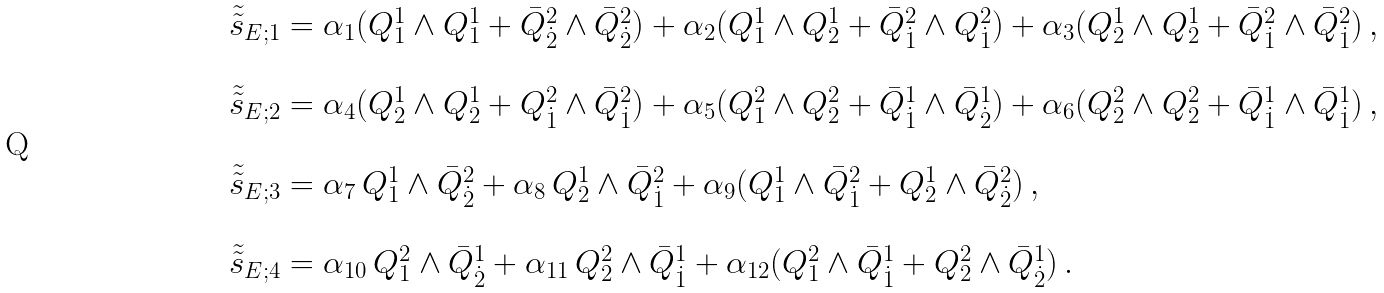<formula> <loc_0><loc_0><loc_500><loc_500>\begin{array} { l } { \tilde { \tilde { s } } } _ { E ; 1 } = \alpha _ { 1 } ( Q ^ { 1 } _ { 1 } \wedge Q ^ { 1 } _ { 1 } + \bar { Q } ^ { 2 } _ { \dot { 2 } } \wedge \bar { Q } ^ { 2 } _ { \dot { 2 } } ) + \alpha _ { 2 } ( Q ^ { 1 } _ { 1 } \wedge Q ^ { 1 } _ { 2 } + \bar { Q } ^ { 2 } _ { \dot { 1 } } \wedge { Q } ^ { 2 } _ { \dot { 1 } } ) + \alpha _ { 3 } ( Q ^ { 1 } _ { 2 } \wedge Q ^ { 1 } _ { 2 } + \bar { Q } ^ { 2 } _ { \dot { 1 } } \wedge \bar { Q } ^ { 2 } _ { \dot { 1 } } ) \, , \\ \\ { \tilde { \tilde { s } } } _ { E ; 2 } = \alpha _ { 4 } ( Q ^ { 1 } _ { 2 } \wedge Q ^ { 1 } _ { 2 } + { Q } ^ { 2 } _ { \dot { 1 } } \wedge \bar { Q } ^ { 2 } _ { \dot { 1 } } ) + \alpha _ { 5 } ( Q ^ { 2 } _ { 1 } \wedge Q ^ { 2 } _ { 2 } + \bar { Q } ^ { 1 } _ { \dot { 1 } } \wedge \bar { Q } ^ { 1 } _ { \dot { 2 } } ) + \alpha _ { 6 } ( Q ^ { 2 } _ { 2 } \wedge Q ^ { 2 } _ { 2 } + \bar { Q } ^ { 1 } _ { \dot { 1 } } \wedge \bar { Q } ^ { 1 } _ { \dot { 1 } } ) \, , \\ \\ { \tilde { \tilde { s } } } _ { E ; 3 } = \alpha _ { 7 } \, Q ^ { 1 } _ { 1 } \wedge \bar { Q } ^ { 2 } _ { \dot { 2 } } + \alpha _ { 8 } \, Q ^ { 1 } _ { 2 } \wedge \bar { Q } ^ { 2 } _ { \dot { 1 } } + \alpha _ { 9 } ( Q ^ { 1 } _ { 1 } \wedge \bar { Q } ^ { 2 } _ { \dot { 1 } } + { Q } ^ { 1 } _ { 2 } \wedge \bar { Q } ^ { 2 } _ { \dot { 2 } } ) \, , \\ \\ { \tilde { \tilde { s } } } _ { E ; 4 } = \alpha _ { 1 0 } \, Q ^ { 2 } _ { 1 } \wedge \bar { Q } ^ { 1 } _ { \dot { 2 } } + \alpha _ { 1 1 } \, Q ^ { 2 } _ { 2 } \wedge \bar { Q } ^ { 1 } _ { \dot { 1 } } + \alpha _ { 1 2 } ( Q ^ { 2 } _ { 1 } \wedge \bar { Q } ^ { 1 } _ { \dot { 1 } } + { Q } ^ { 2 } _ { 2 } \wedge \bar { Q } ^ { 1 } _ { \dot { 2 } } ) \, . \end{array}</formula> 